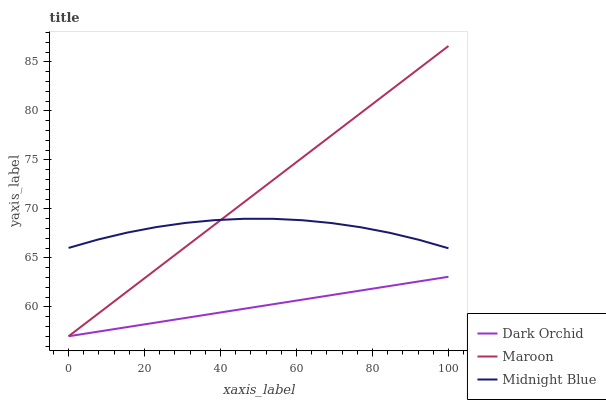Does Midnight Blue have the minimum area under the curve?
Answer yes or no. No. Does Midnight Blue have the maximum area under the curve?
Answer yes or no. No. Is Midnight Blue the smoothest?
Answer yes or no. No. Is Dark Orchid the roughest?
Answer yes or no. No. Does Midnight Blue have the lowest value?
Answer yes or no. No. Does Midnight Blue have the highest value?
Answer yes or no. No. Is Dark Orchid less than Midnight Blue?
Answer yes or no. Yes. Is Midnight Blue greater than Dark Orchid?
Answer yes or no. Yes. Does Dark Orchid intersect Midnight Blue?
Answer yes or no. No. 